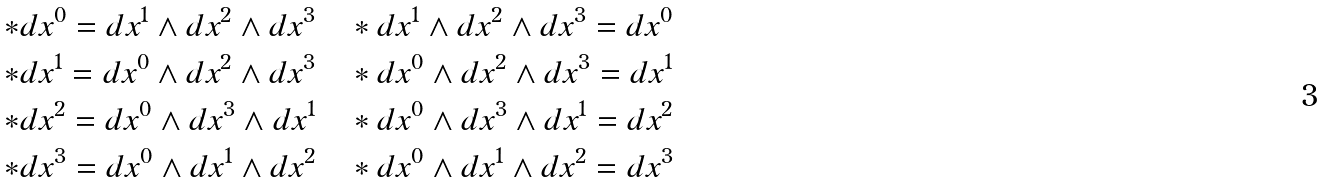Convert formula to latex. <formula><loc_0><loc_0><loc_500><loc_500>* d x ^ { 0 } = d x ^ { 1 } \wedge d x ^ { 2 } \wedge d x ^ { 3 } \quad & * d x ^ { 1 } \wedge d x ^ { 2 } \wedge d x ^ { 3 } = d x ^ { 0 } \\ * d x ^ { 1 } = d x ^ { 0 } \wedge d x ^ { 2 } \wedge d x ^ { 3 } \quad & * d x ^ { 0 } \wedge d x ^ { 2 } \wedge d x ^ { 3 } = d x ^ { 1 } \\ * d x ^ { 2 } = d x ^ { 0 } \wedge d x ^ { 3 } \wedge d x ^ { 1 } \quad & * d x ^ { 0 } \wedge d x ^ { 3 } \wedge d x ^ { 1 } = d x ^ { 2 } \\ * d x ^ { 3 } = d x ^ { 0 } \wedge d x ^ { 1 } \wedge d x ^ { 2 } \quad & * d x ^ { 0 } \wedge d x ^ { 1 } \wedge d x ^ { 2 } = d x ^ { 3 }</formula> 